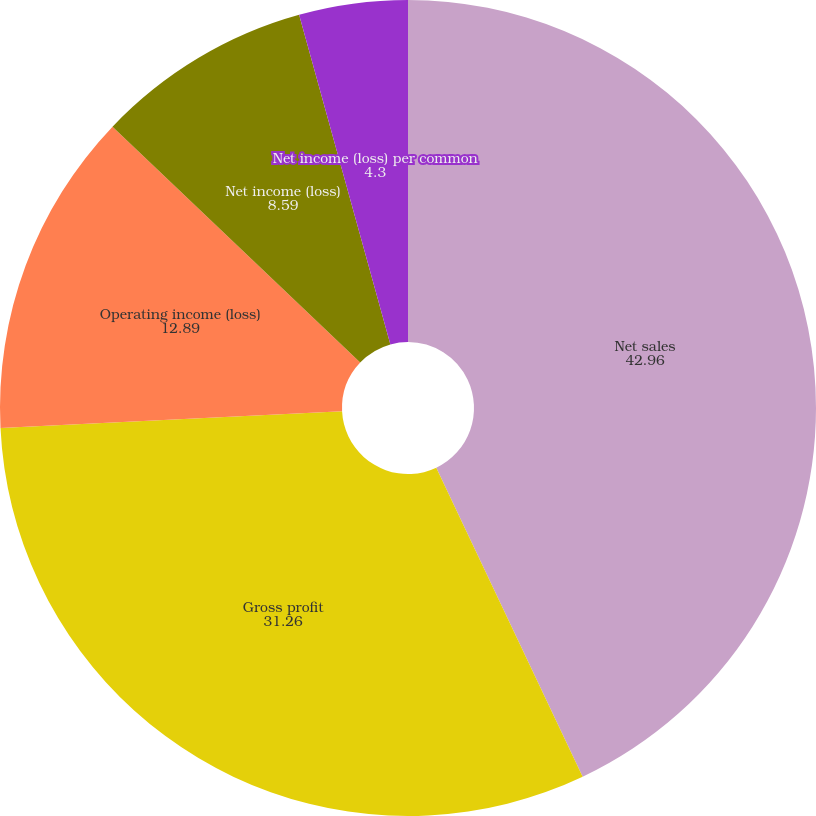Convert chart to OTSL. <chart><loc_0><loc_0><loc_500><loc_500><pie_chart><fcel>Net sales<fcel>Gross profit<fcel>Operating income (loss)<fcel>Net income (loss)<fcel>Net income (loss) per common<nl><fcel>42.96%<fcel>31.26%<fcel>12.89%<fcel>8.59%<fcel>4.3%<nl></chart> 